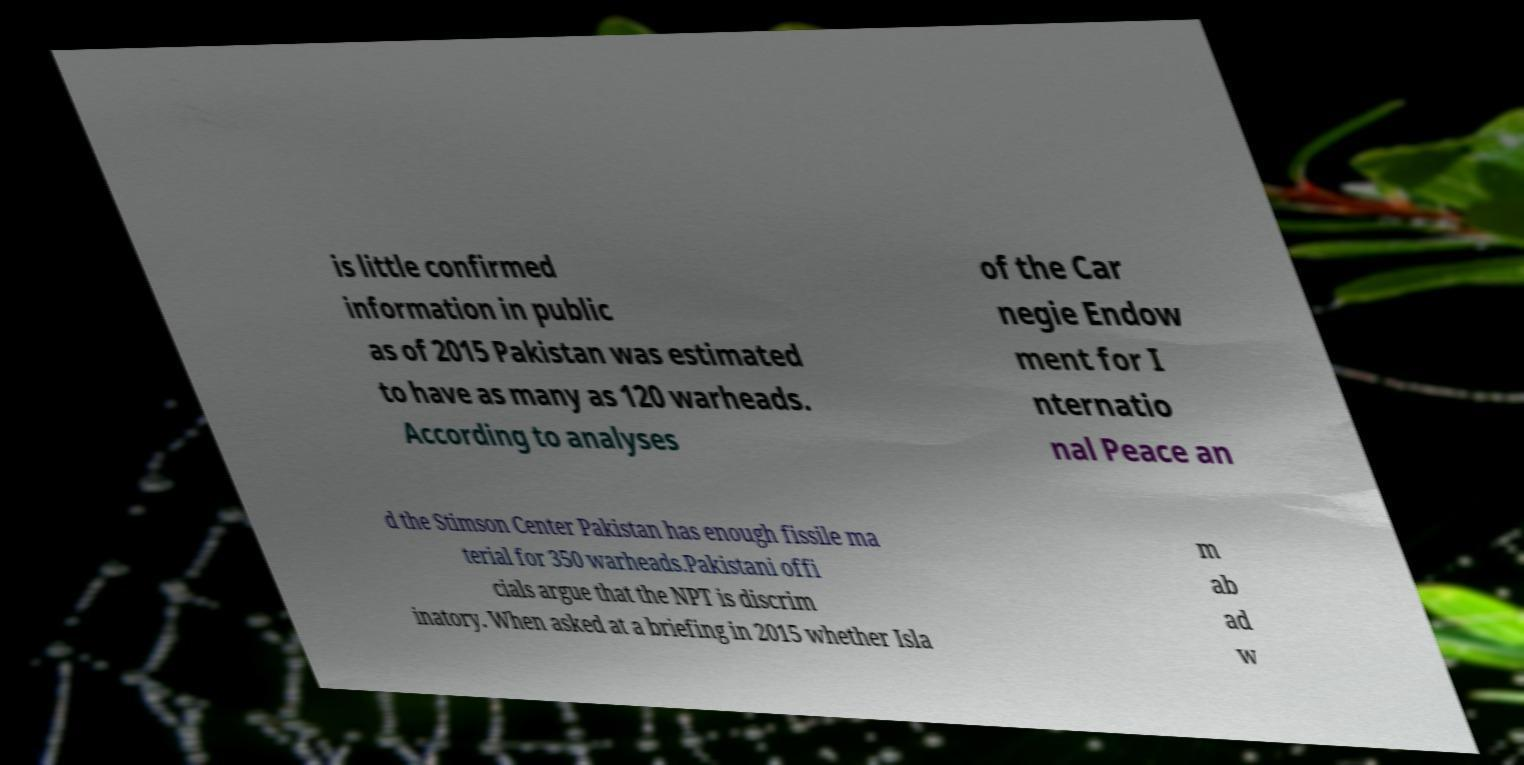There's text embedded in this image that I need extracted. Can you transcribe it verbatim? is little confirmed information in public as of 2015 Pakistan was estimated to have as many as 120 warheads. According to analyses of the Car negie Endow ment for I nternatio nal Peace an d the Stimson Center Pakistan has enough fissile ma terial for 350 warheads.Pakistani offi cials argue that the NPT is discrim inatory. When asked at a briefing in 2015 whether Isla m ab ad w 